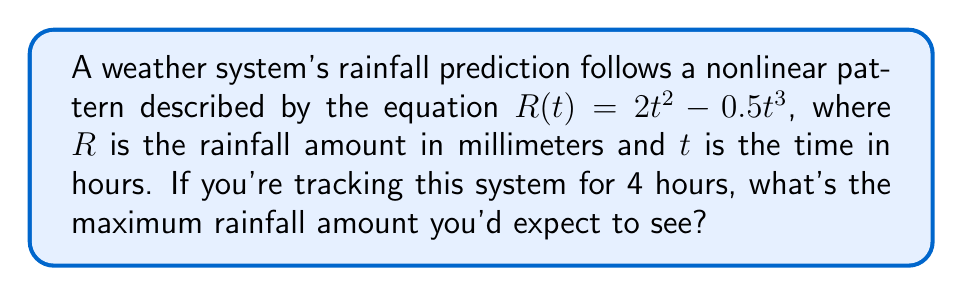Help me with this question. To find the maximum rainfall amount, we need to follow these steps:

1) First, we need to find the critical points of the function $R(t) = 2t^2 - 0.5t^3$. To do this, we take the derivative and set it equal to zero:

   $$\frac{dR}{dt} = 4t - 1.5t^2$$
   $$4t - 1.5t^2 = 0$$

2) Factor out t:
   $$t(4 - 1.5t) = 0$$

3) Solve for t:
   $t = 0$ or $4 - 1.5t = 0$
   $t = 0$ or $t = \frac{8}{3}$

4) We're only interested in positive time values between 0 and 4 hours, so we'll consider $t = 0$ and $t = \frac{8}{3}$.

5) Now, we need to evaluate $R(t)$ at these points and at the endpoint $t = 4$:

   $R(0) = 2(0)^2 - 0.5(0)^3 = 0$

   $R(\frac{8}{3}) = 2(\frac{8}{3})^2 - 0.5(\frac{8}{3})^3 = \frac{128}{9} - \frac{256}{27} = \frac{128}{27} \approx 4.74$ mm

   $R(4) = 2(4)^2 - 0.5(4)^3 = 32 - 32 = 0$

6) The maximum of these values is $\frac{128}{27}$ mm, which occurs at $t = \frac{8}{3}$ hours.
Answer: $\frac{128}{27}$ mm 